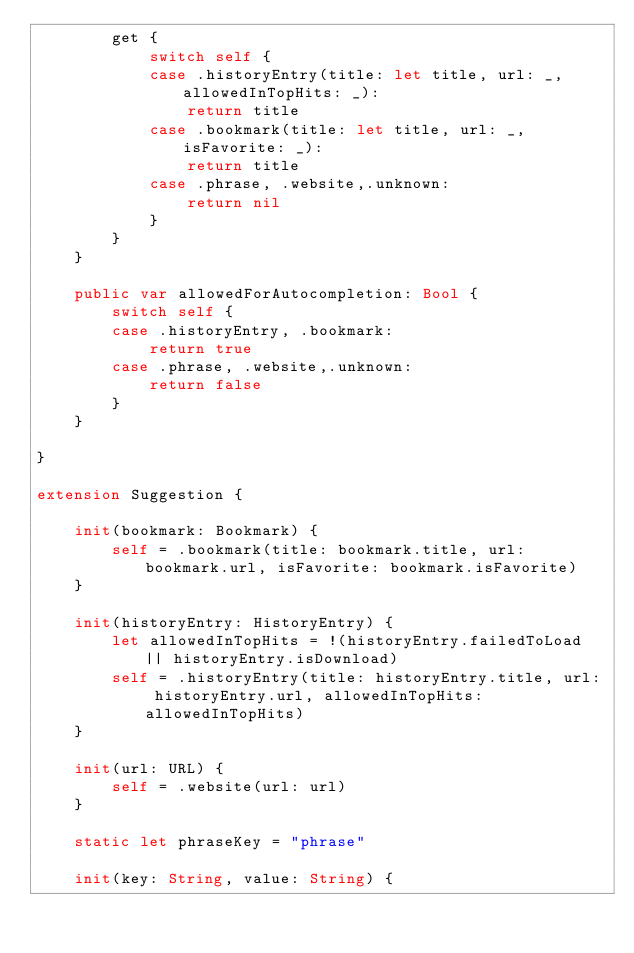<code> <loc_0><loc_0><loc_500><loc_500><_Swift_>        get {
            switch self {
            case .historyEntry(title: let title, url: _, allowedInTopHits: _):
                return title
            case .bookmark(title: let title, url: _, isFavorite: _):
                return title
            case .phrase, .website,.unknown:
                return nil
            }
        }
    }

    public var allowedForAutocompletion: Bool {
        switch self {
        case .historyEntry, .bookmark:
            return true
        case .phrase, .website,.unknown:
            return false
        }
    }

}

extension Suggestion {

    init(bookmark: Bookmark) {
        self = .bookmark(title: bookmark.title, url: bookmark.url, isFavorite: bookmark.isFavorite)
    }

    init(historyEntry: HistoryEntry) {
        let allowedInTopHits = !(historyEntry.failedToLoad || historyEntry.isDownload)
        self = .historyEntry(title: historyEntry.title, url: historyEntry.url, allowedInTopHits: allowedInTopHits)
    }

    init(url: URL) {
        self = .website(url: url)
    }

    static let phraseKey = "phrase"

    init(key: String, value: String) {</code> 